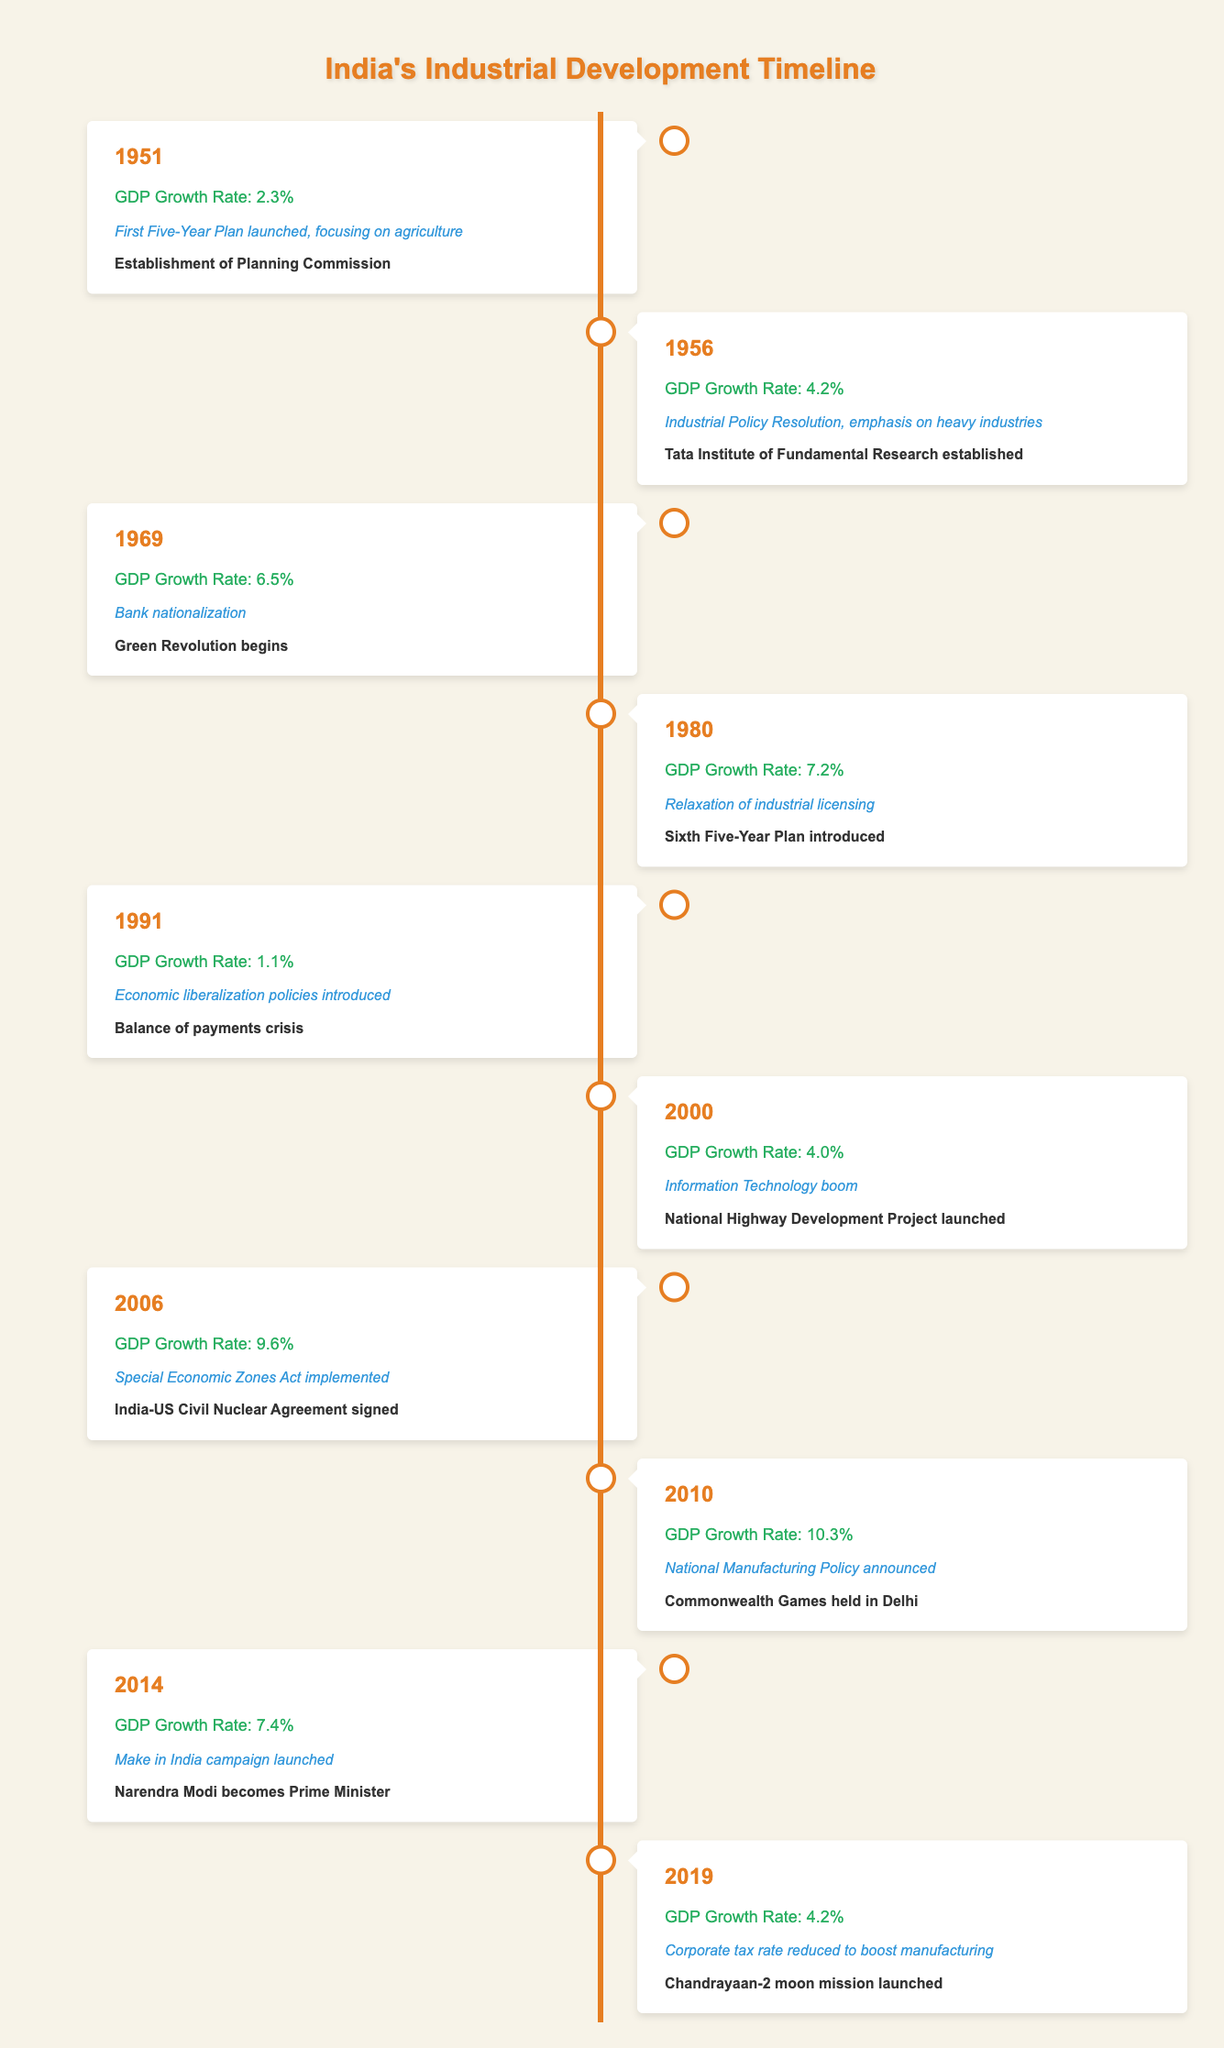What was India's GDP growth rate in 1980? Referring to the table, the GDP growth rate listed for the year 1980 is 7.2%.
Answer: 7.2% Which industrial development milestone was achieved in 2014? In 2014, the milestone was the launch of the "Make in India" campaign.
Answer: Make in India campaign launched What was the GDP growth rate difference between 2006 and 2010? The GDP growth rate in 2006 was 9.6% and in 2010 it was 10.3%. The difference is 10.3% - 9.6% = 0.7%.
Answer: 0.7% Was the GDP growth rate higher in 1969 than in 2019? Yes, in 1969 the GDP growth rate was 6.5%, while in 2019 it was 4.2%. This confirms that the earlier rate was indeed higher.
Answer: Yes What was the average GDP growth rate from 2000 to 2014? The growth rates from 2000 to 2014 are 4.0% (2000), 9.6% (2006), 10.3% (2010), and 7.4% (2014). The average is (4.0 + 9.6 + 10.3 + 7.4) / 4 = 7.825%.
Answer: 7.825% What notable event occurred in 1991? The table indicates that in 1991, the notable event was the balance of payments crisis.
Answer: Balance of payments crisis Which year had the lowest GDP growth rate in the timeline? By checking the table, the lowest GDP growth rate is 1.1%, which occurred in 1991.
Answer: 1991 How many years had a GDP growth rate above 7% up to 2014? The years with above 7% GDP growth are 2006 (9.6%), 2010 (10.3%), and 2014 (7.4%). This totals 3 years.
Answer: 3 years What trend can be observed between industrial development milestones and GDP growth rates from 1951 to 2014? Observing the data, as industrial development milestones were established and advanced, there was a general upward trend in GDP growth rates, particularly notable after 2006.
Answer: Positive trend observed 